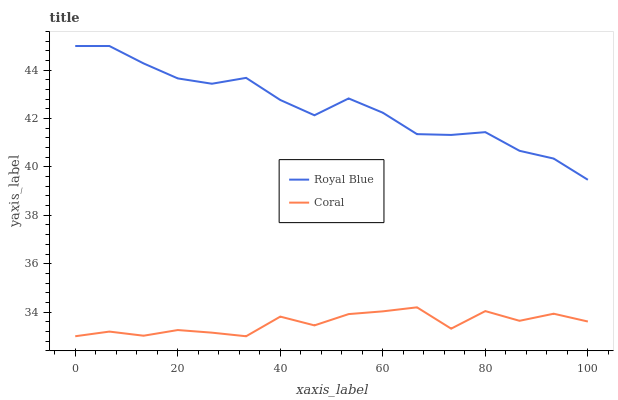Does Coral have the minimum area under the curve?
Answer yes or no. Yes. Does Royal Blue have the maximum area under the curve?
Answer yes or no. Yes. Does Coral have the maximum area under the curve?
Answer yes or no. No. Is Royal Blue the smoothest?
Answer yes or no. Yes. Is Coral the roughest?
Answer yes or no. Yes. Is Coral the smoothest?
Answer yes or no. No. Does Coral have the lowest value?
Answer yes or no. Yes. Does Royal Blue have the highest value?
Answer yes or no. Yes. Does Coral have the highest value?
Answer yes or no. No. Is Coral less than Royal Blue?
Answer yes or no. Yes. Is Royal Blue greater than Coral?
Answer yes or no. Yes. Does Coral intersect Royal Blue?
Answer yes or no. No. 